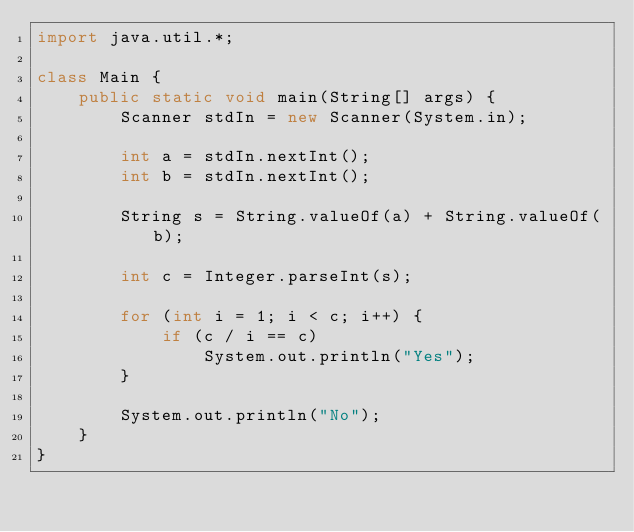Convert code to text. <code><loc_0><loc_0><loc_500><loc_500><_Java_>import java.util.*;

class Main {
    public static void main(String[] args) {
        Scanner stdIn = new Scanner(System.in);

        int a = stdIn.nextInt();
        int b = stdIn.nextInt();

        String s = String.valueOf(a) + String.valueOf(b);

        int c = Integer.parseInt(s);

        for (int i = 1; i < c; i++) {
            if (c / i == c)
                System.out.println("Yes");
        }

        System.out.println("No");
    }
}</code> 